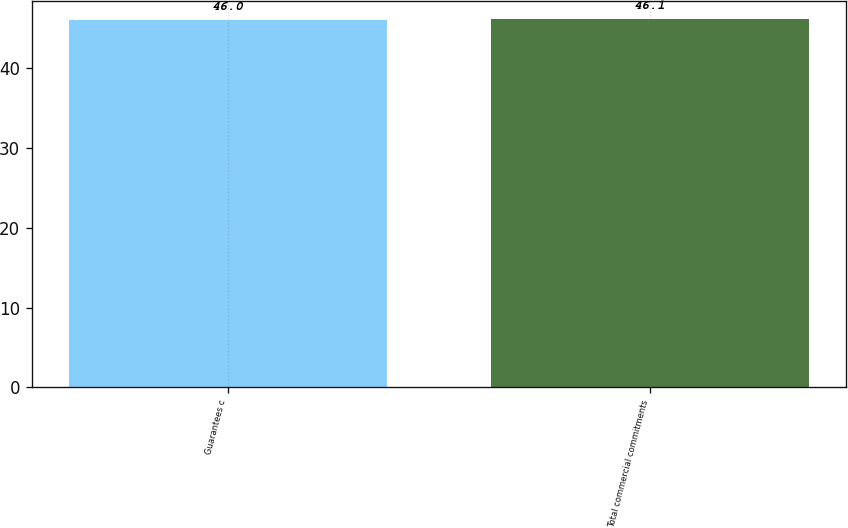Convert chart to OTSL. <chart><loc_0><loc_0><loc_500><loc_500><bar_chart><fcel>Guarantees c<fcel>Total commercial commitments<nl><fcel>46<fcel>46.1<nl></chart> 